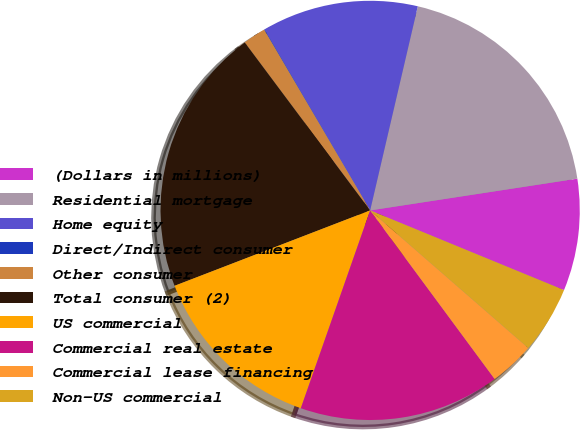Convert chart. <chart><loc_0><loc_0><loc_500><loc_500><pie_chart><fcel>(Dollars in millions)<fcel>Residential mortgage<fcel>Home equity<fcel>Direct/Indirect consumer<fcel>Other consumer<fcel>Total consumer (2)<fcel>US commercial<fcel>Commercial real estate<fcel>Commercial lease financing<fcel>Non-US commercial<nl><fcel>8.63%<fcel>18.93%<fcel>12.06%<fcel>0.04%<fcel>1.76%<fcel>20.65%<fcel>13.78%<fcel>15.49%<fcel>3.48%<fcel>5.19%<nl></chart> 